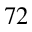Convert formula to latex. <formula><loc_0><loc_0><loc_500><loc_500>7 2</formula> 